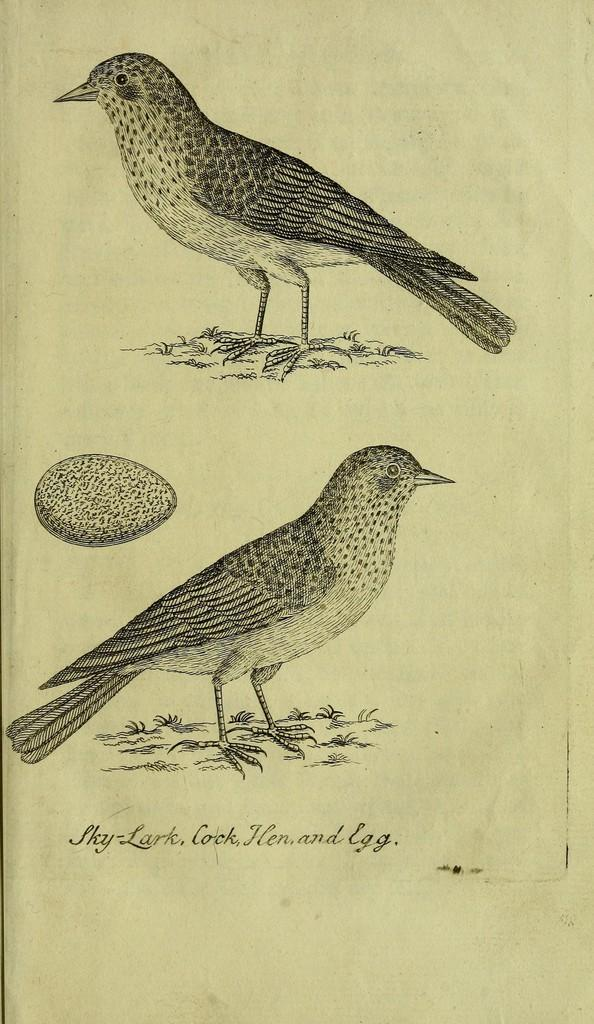What type of animals are depicted on the paper in the image? There are depictions of birds on the paper. What other objects are depicted on the paper? There are depictions of eggs on the paper. What else can be seen on the paper besides the images? There is some text on the paper. What type of glove is being used to rate the disease in the image? There is no glove or disease present in the image; it features depictions of birds and eggs on a paper with some text. 